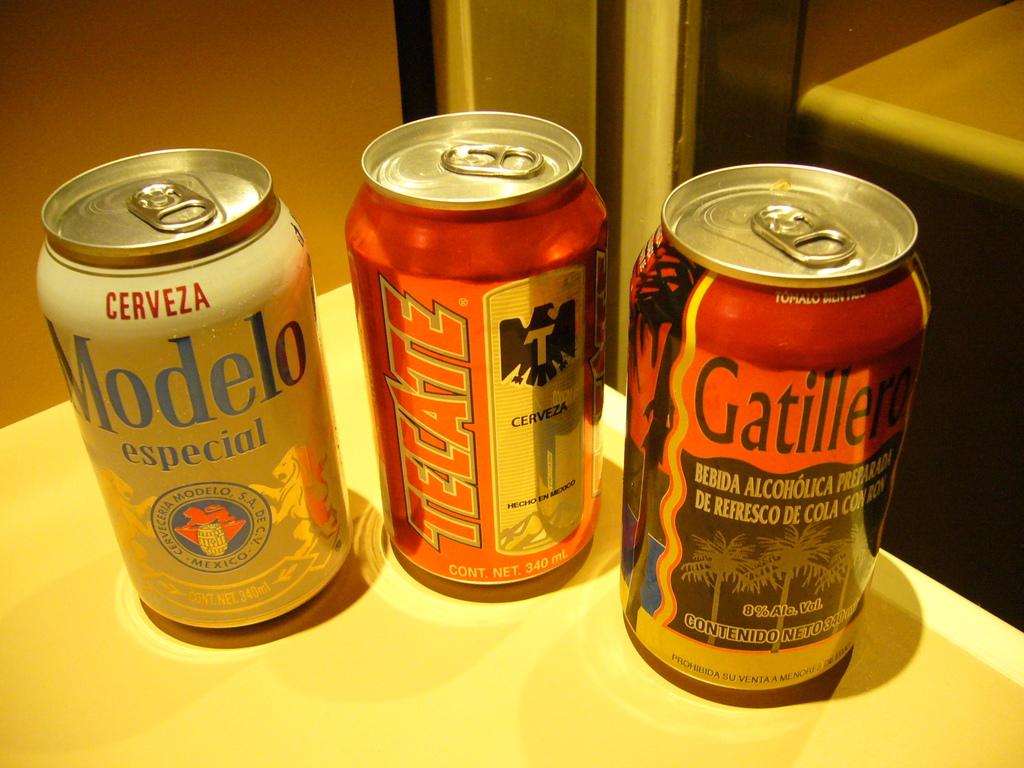What brand of beer is in the middle can?
Provide a short and direct response. Tecate. What brand of beer is on the very left?
Your answer should be very brief. Modelo. 